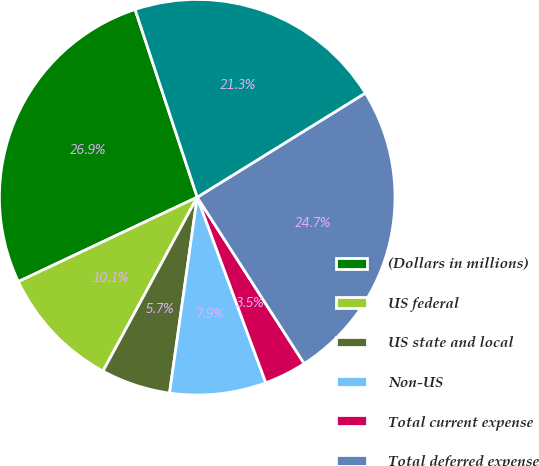Convert chart to OTSL. <chart><loc_0><loc_0><loc_500><loc_500><pie_chart><fcel>(Dollars in millions)<fcel>US federal<fcel>US state and local<fcel>Non-US<fcel>Total current expense<fcel>Total deferred expense<fcel>Total income tax expense<nl><fcel>26.93%<fcel>10.08%<fcel>5.67%<fcel>7.87%<fcel>3.46%<fcel>24.73%<fcel>21.26%<nl></chart> 